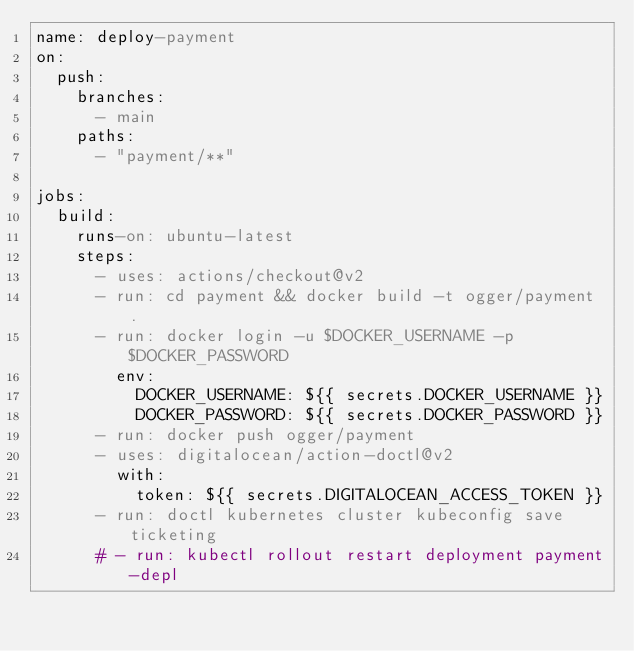Convert code to text. <code><loc_0><loc_0><loc_500><loc_500><_YAML_>name: deploy-payment
on:
  push:
    branches:
      - main
    paths:
      - "payment/**"

jobs:
  build:
    runs-on: ubuntu-latest
    steps:
      - uses: actions/checkout@v2
      - run: cd payment && docker build -t ogger/payment .
      - run: docker login -u $DOCKER_USERNAME -p $DOCKER_PASSWORD
        env:
          DOCKER_USERNAME: ${{ secrets.DOCKER_USERNAME }}
          DOCKER_PASSWORD: ${{ secrets.DOCKER_PASSWORD }}
      - run: docker push ogger/payment
      - uses: digitalocean/action-doctl@v2
        with:
          token: ${{ secrets.DIGITALOCEAN_ACCESS_TOKEN }}
      - run: doctl kubernetes cluster kubeconfig save ticketing
      # - run: kubectl rollout restart deployment payment-depl
</code> 